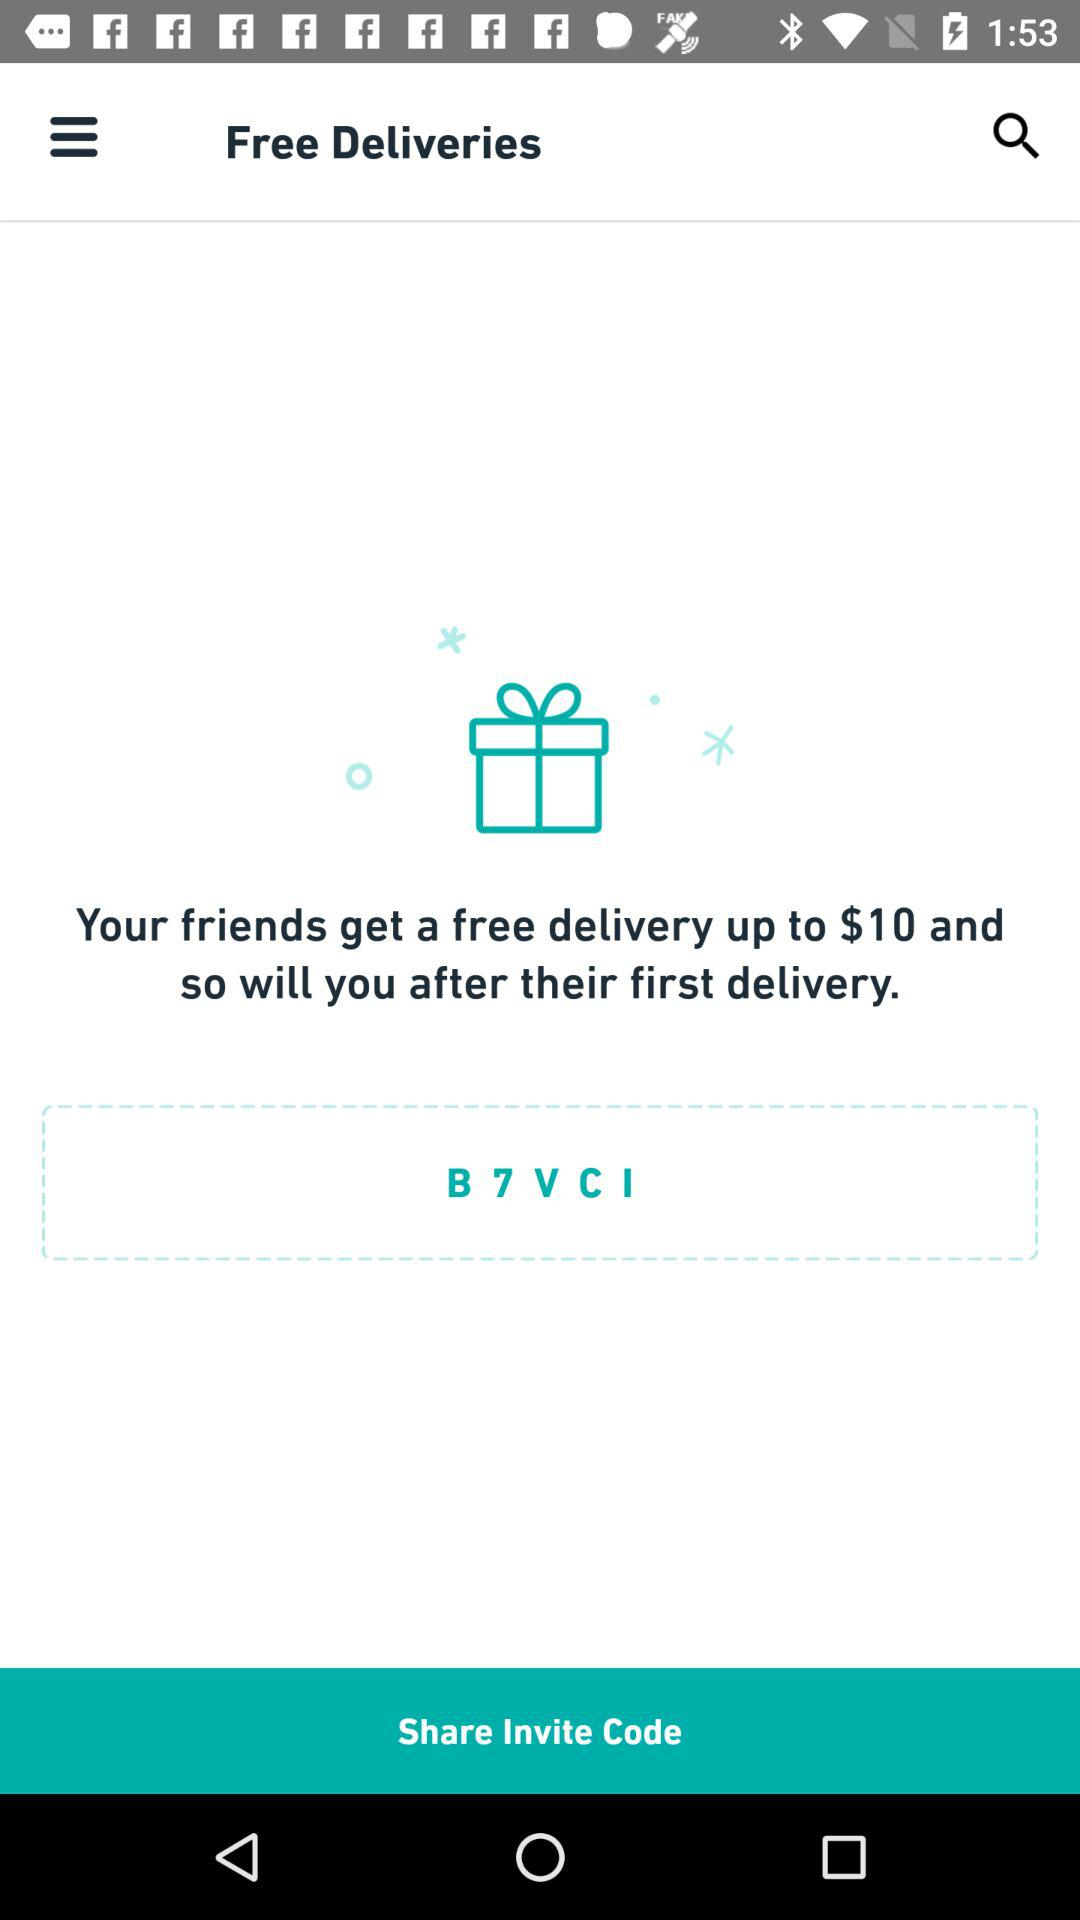What section of the application is shown? The shown section of the application is "Free Deliveries". 